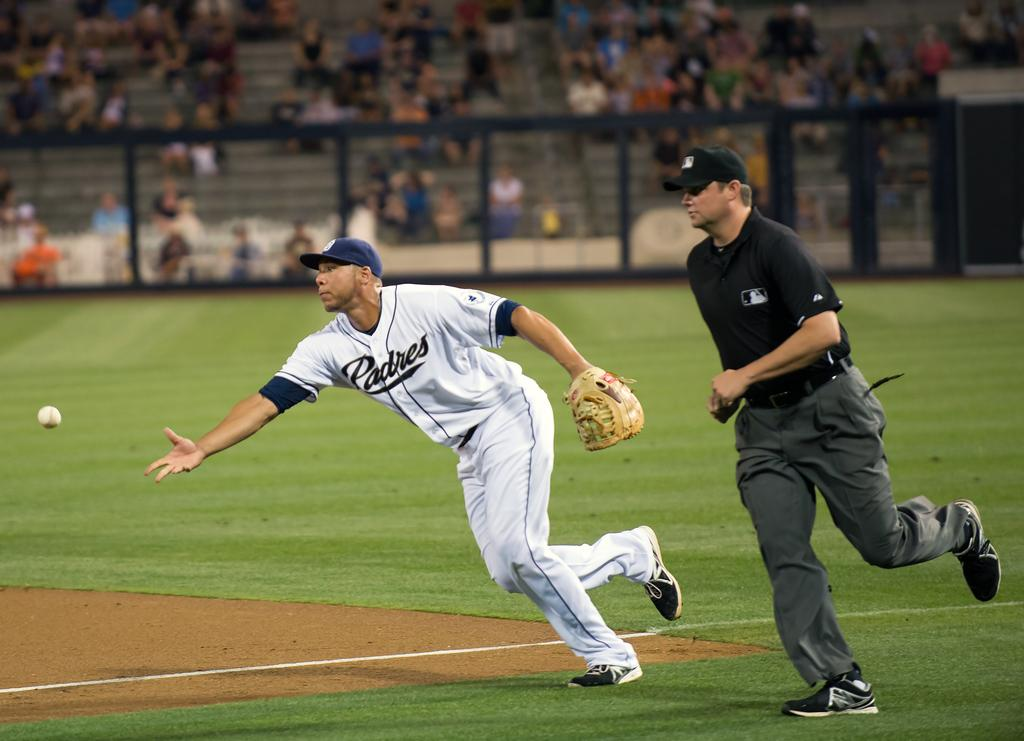<image>
Provide a brief description of the given image. Padres baseball player tossing a baseball with an umpire looking on. 